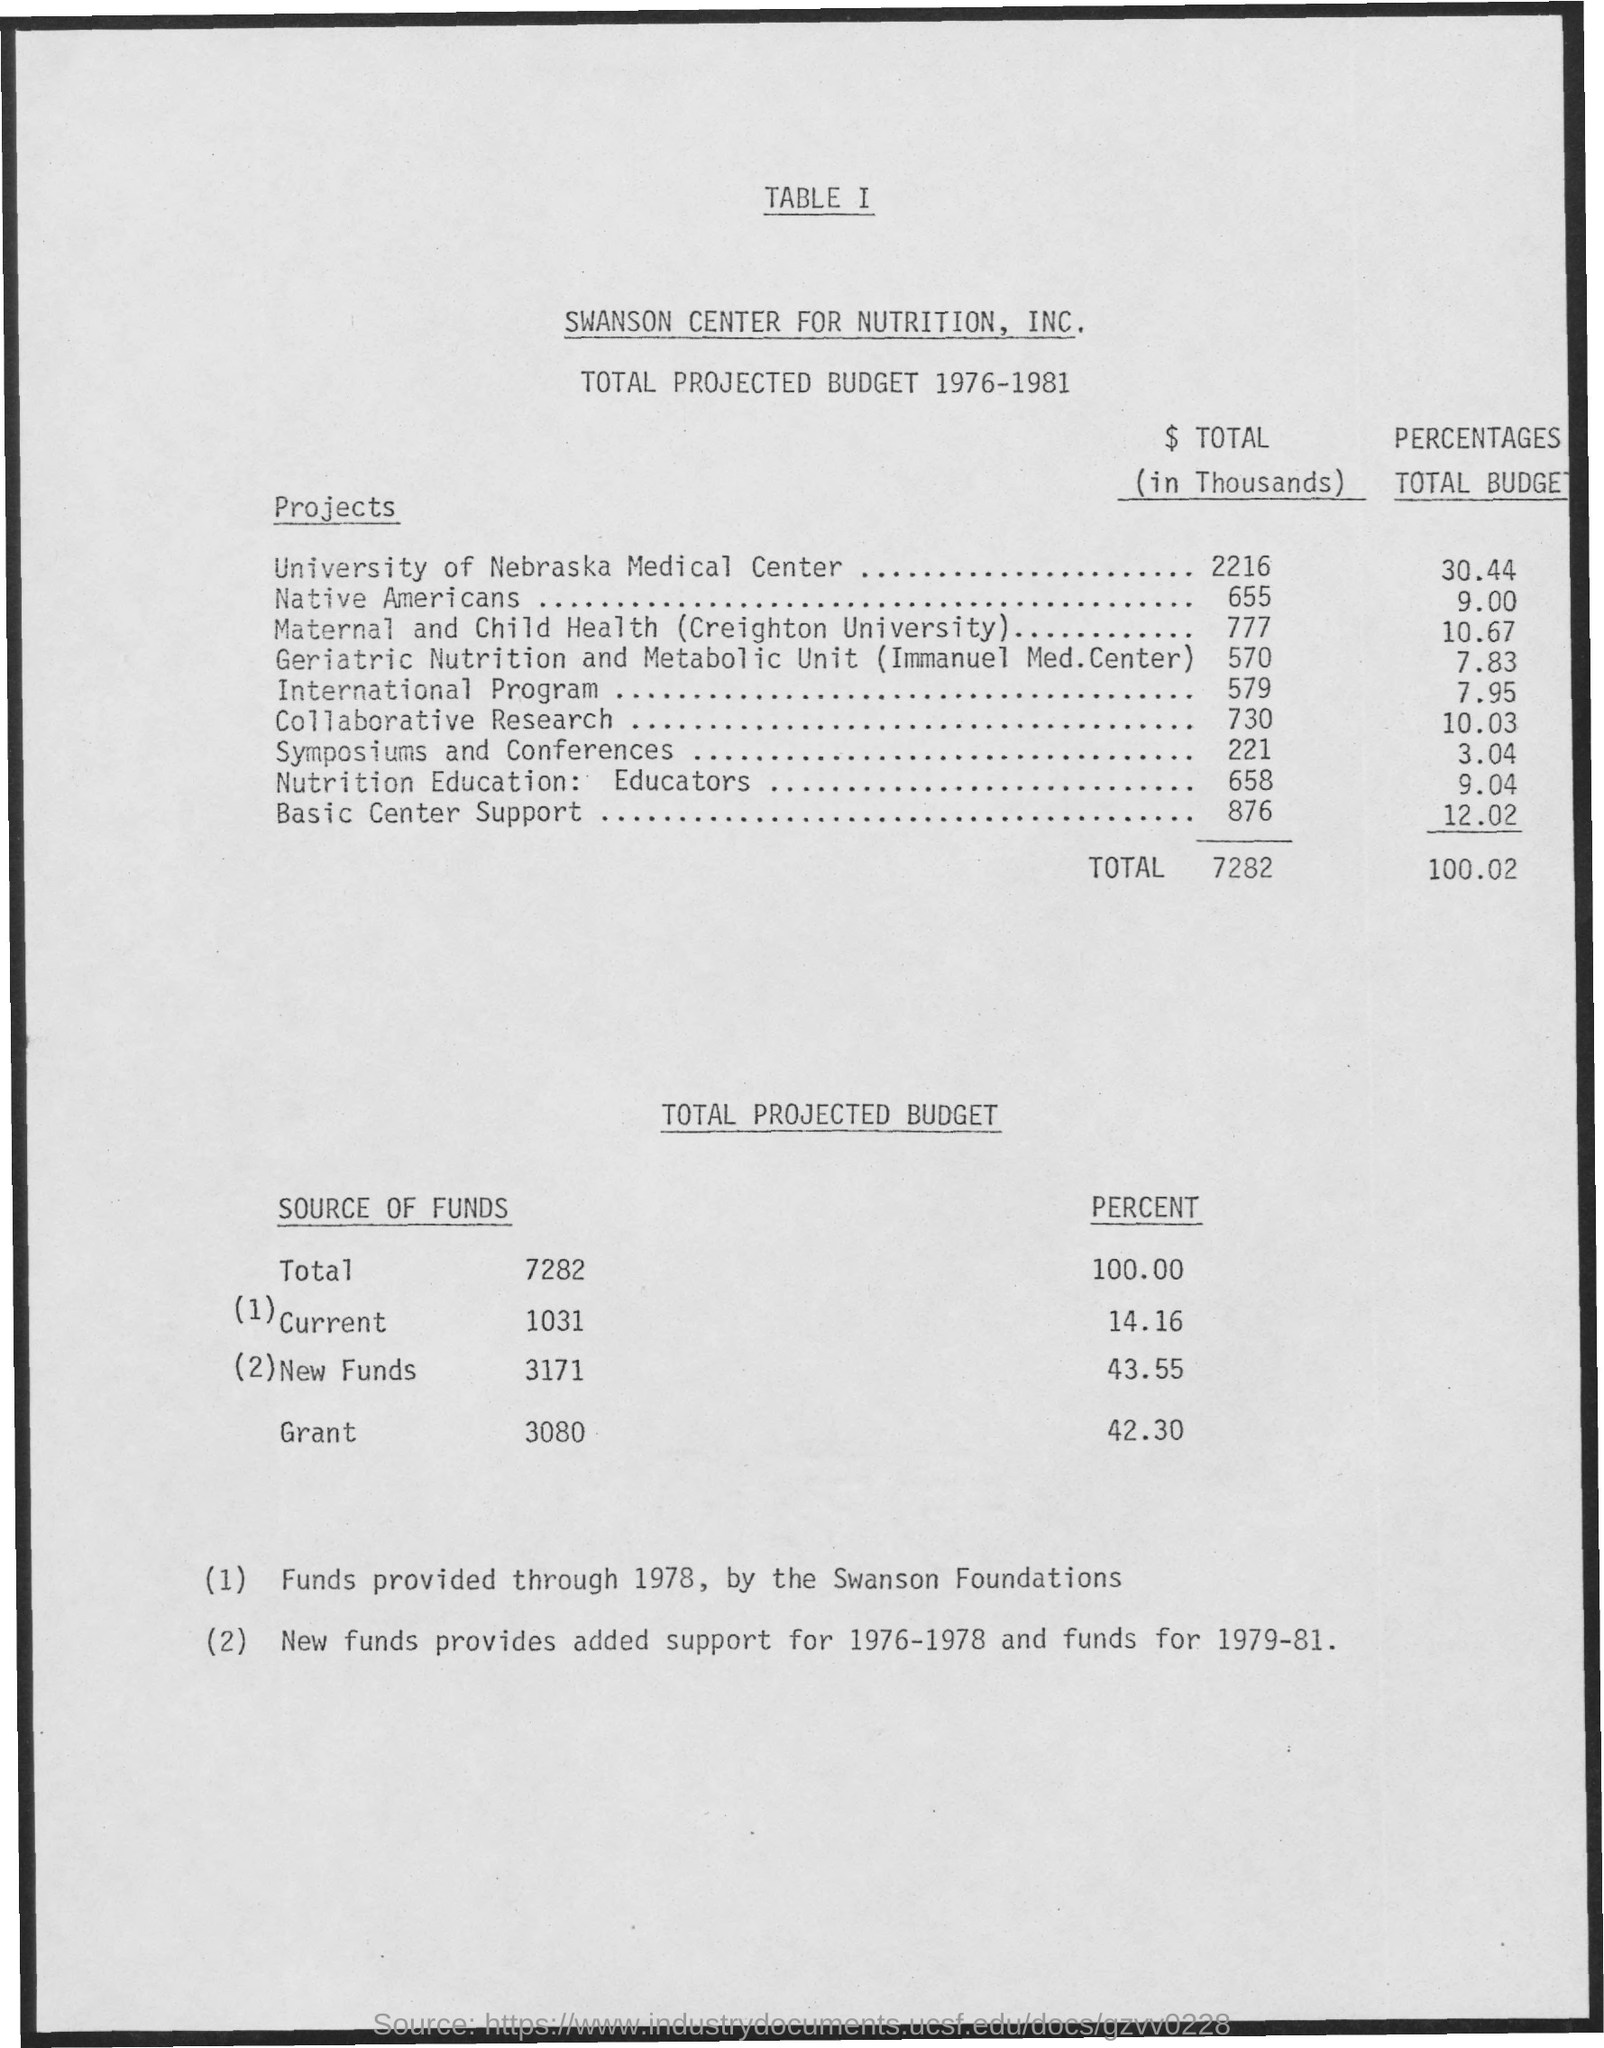Give some essential details in this illustration. The Native American budget of the project represents approximately 9% of the total budget. The International Program's total budget is 7.95% of the overall project budget. According to the information provided, the Swanson Foundations were the sources of funds from 1978 until the present. The total budget of the project Basic Center Support is 12.02%. The University of Nebraska Medical Center's total budget for the project was 30.44%. 